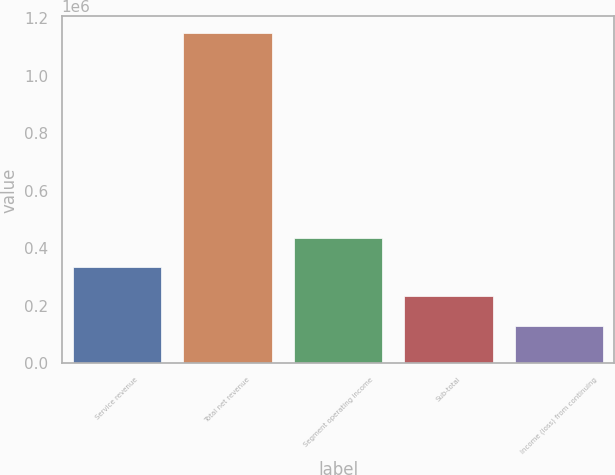<chart> <loc_0><loc_0><loc_500><loc_500><bar_chart><fcel>Service revenue<fcel>Total net revenue<fcel>Segment operating income<fcel>Sub-total<fcel>Income (loss) from continuing<nl><fcel>334123<fcel>1.1484e+06<fcel>435908<fcel>232337<fcel>130552<nl></chart> 